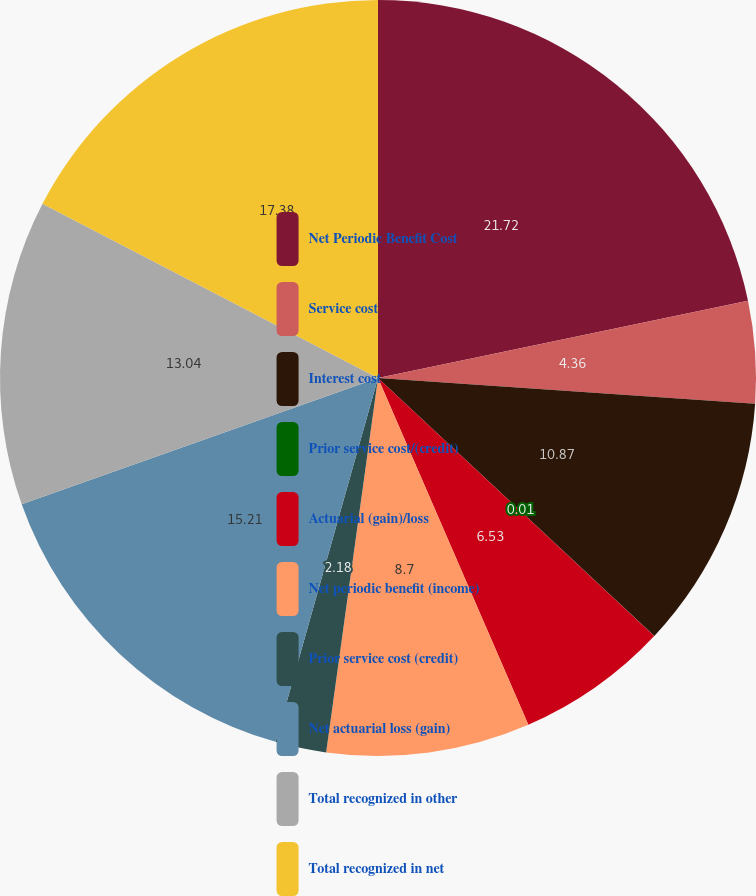<chart> <loc_0><loc_0><loc_500><loc_500><pie_chart><fcel>Net Periodic Benefit Cost<fcel>Service cost<fcel>Interest cost<fcel>Prior service cost/(credit)<fcel>Actuarial (gain)/loss<fcel>Net periodic benefit (income)<fcel>Prior service cost (credit)<fcel>Net actuarial loss (gain)<fcel>Total recognized in other<fcel>Total recognized in net<nl><fcel>21.72%<fcel>4.36%<fcel>10.87%<fcel>0.01%<fcel>6.53%<fcel>8.7%<fcel>2.18%<fcel>15.21%<fcel>13.04%<fcel>17.38%<nl></chart> 